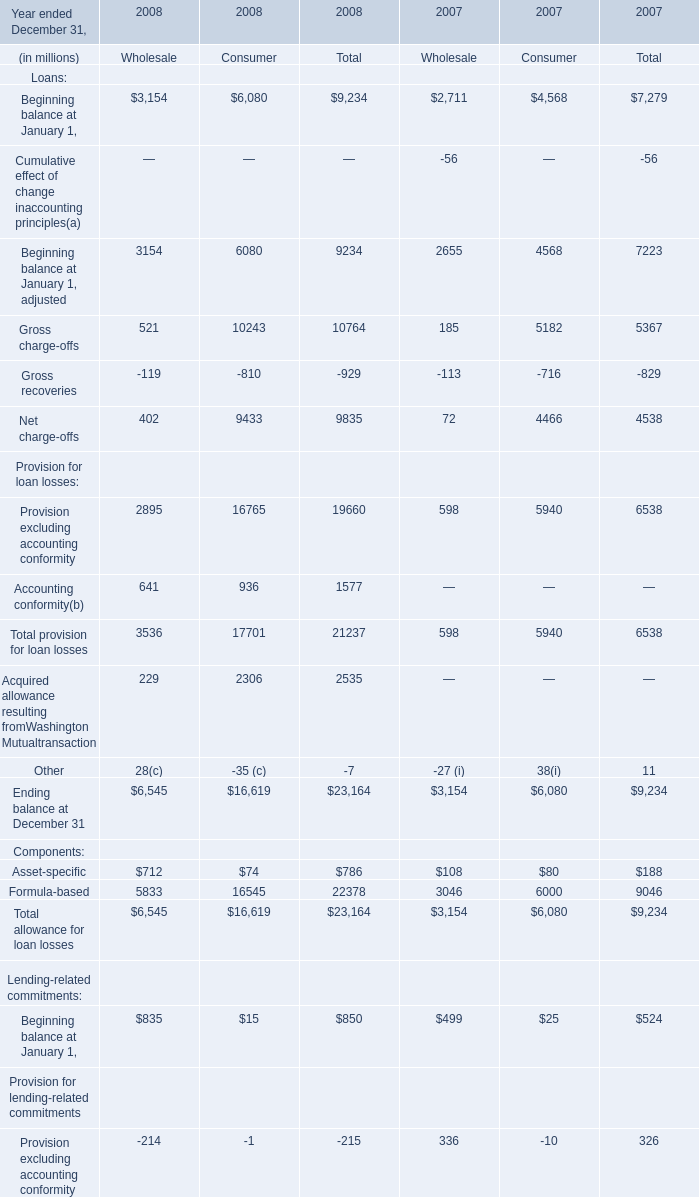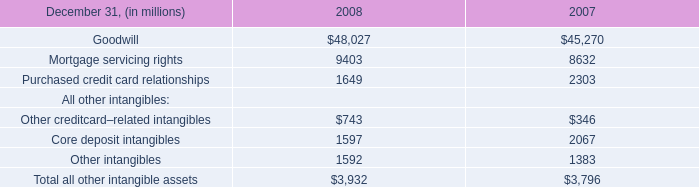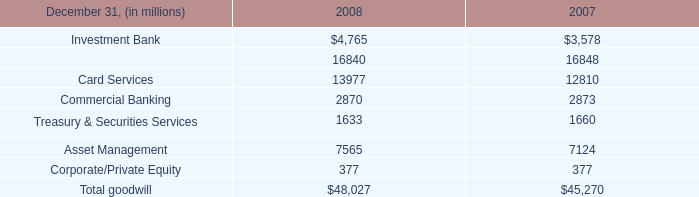What's the sum of the Gross charge-offs in Table 0 in the years where Investment Bank in Table 2 is greater than 4000? (in million) 
Computations: (521 + 10243)
Answer: 10764.0. 